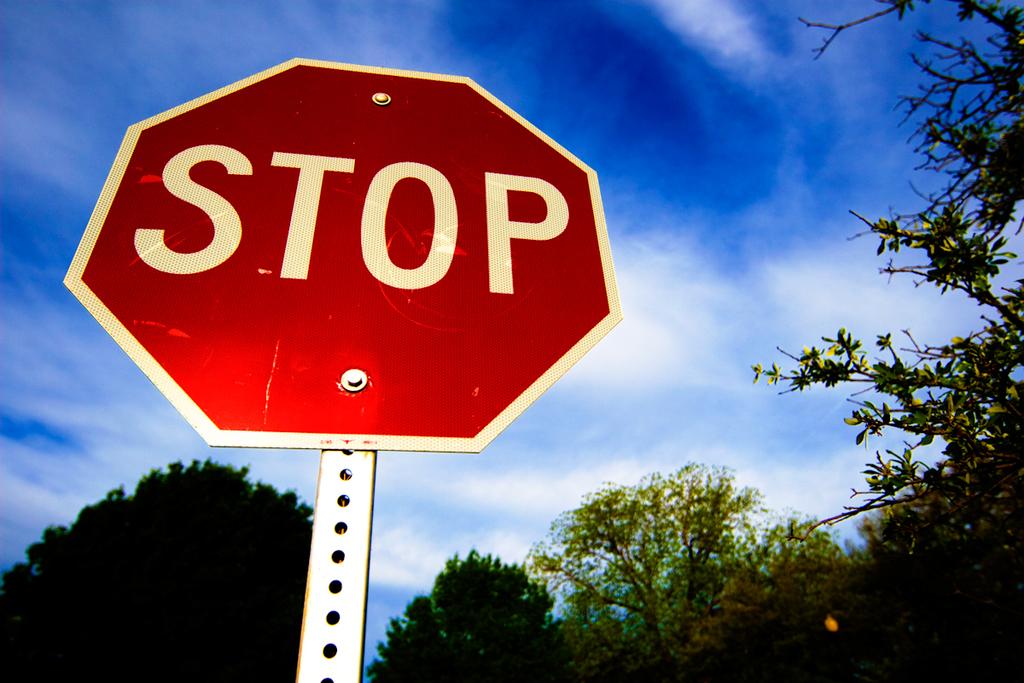Is that a stop sign?
Offer a terse response. Yes. 